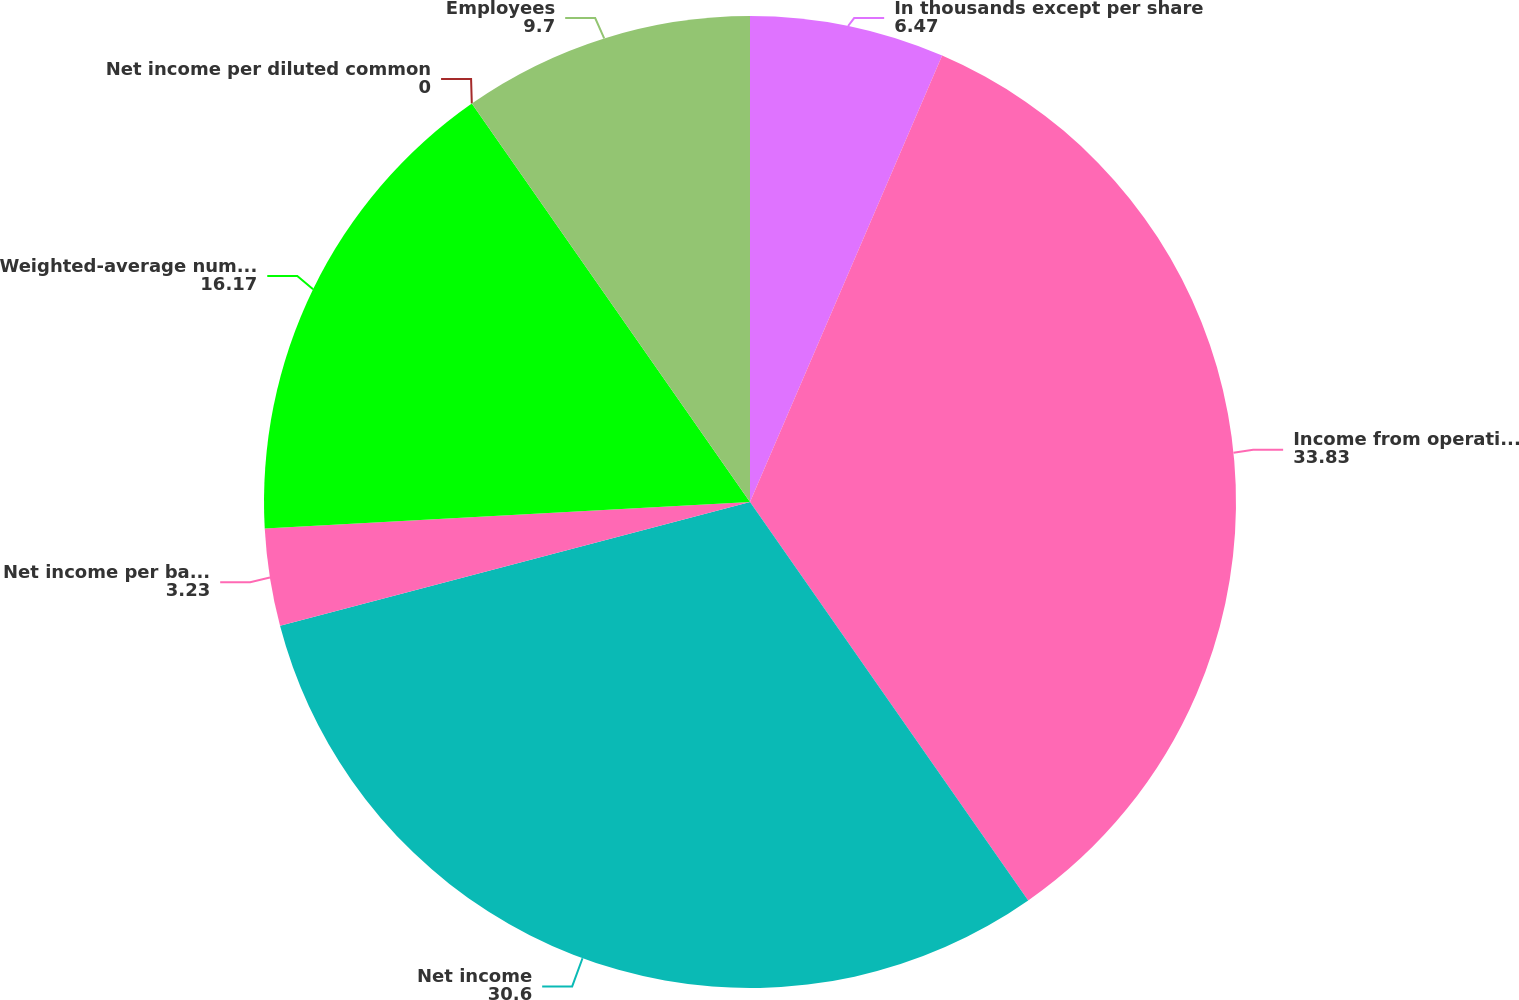<chart> <loc_0><loc_0><loc_500><loc_500><pie_chart><fcel>In thousands except per share<fcel>Income from operations before<fcel>Net income<fcel>Net income per basic common<fcel>Weighted-average number of<fcel>Net income per diluted common<fcel>Employees<nl><fcel>6.47%<fcel>33.83%<fcel>30.6%<fcel>3.23%<fcel>16.17%<fcel>0.0%<fcel>9.7%<nl></chart> 